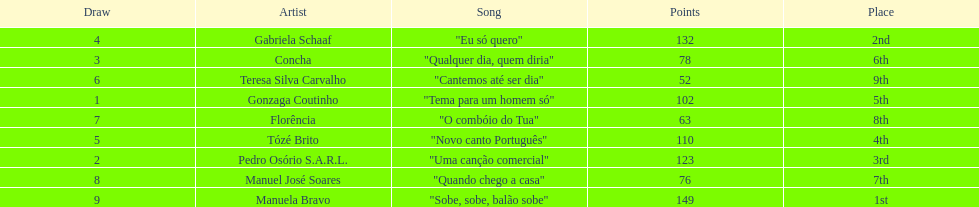Who sang "eu só quero" as their song in the eurovision song contest of 1979? Gabriela Schaaf. 